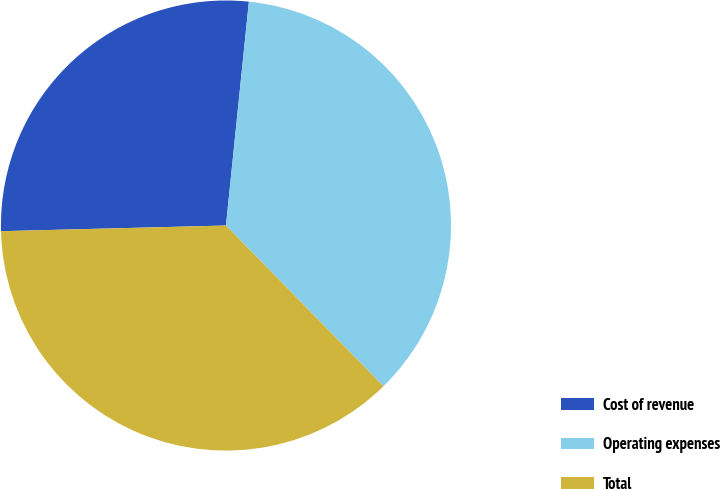<chart> <loc_0><loc_0><loc_500><loc_500><pie_chart><fcel>Cost of revenue<fcel>Operating expenses<fcel>Total<nl><fcel>27.03%<fcel>36.04%<fcel>36.94%<nl></chart> 